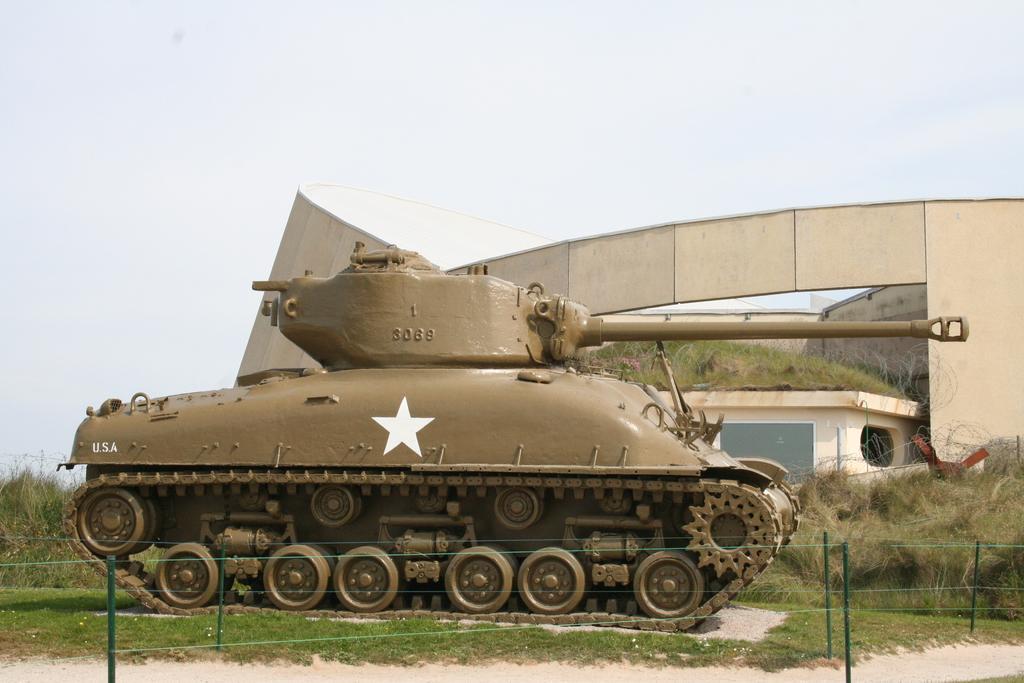Can you describe this image briefly? In this image, we can see a tank on the surface. Here we can see grass, poles, plants and house. Here we can see few objects. Background there is the sky. 